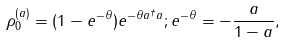Convert formula to latex. <formula><loc_0><loc_0><loc_500><loc_500>\rho _ { 0 } ^ { ( a ) } = ( 1 - e ^ { - \theta } ) e ^ { - \theta a ^ { \dagger } a } ; e ^ { - \theta } = - \frac { a } { 1 - a } ,</formula> 